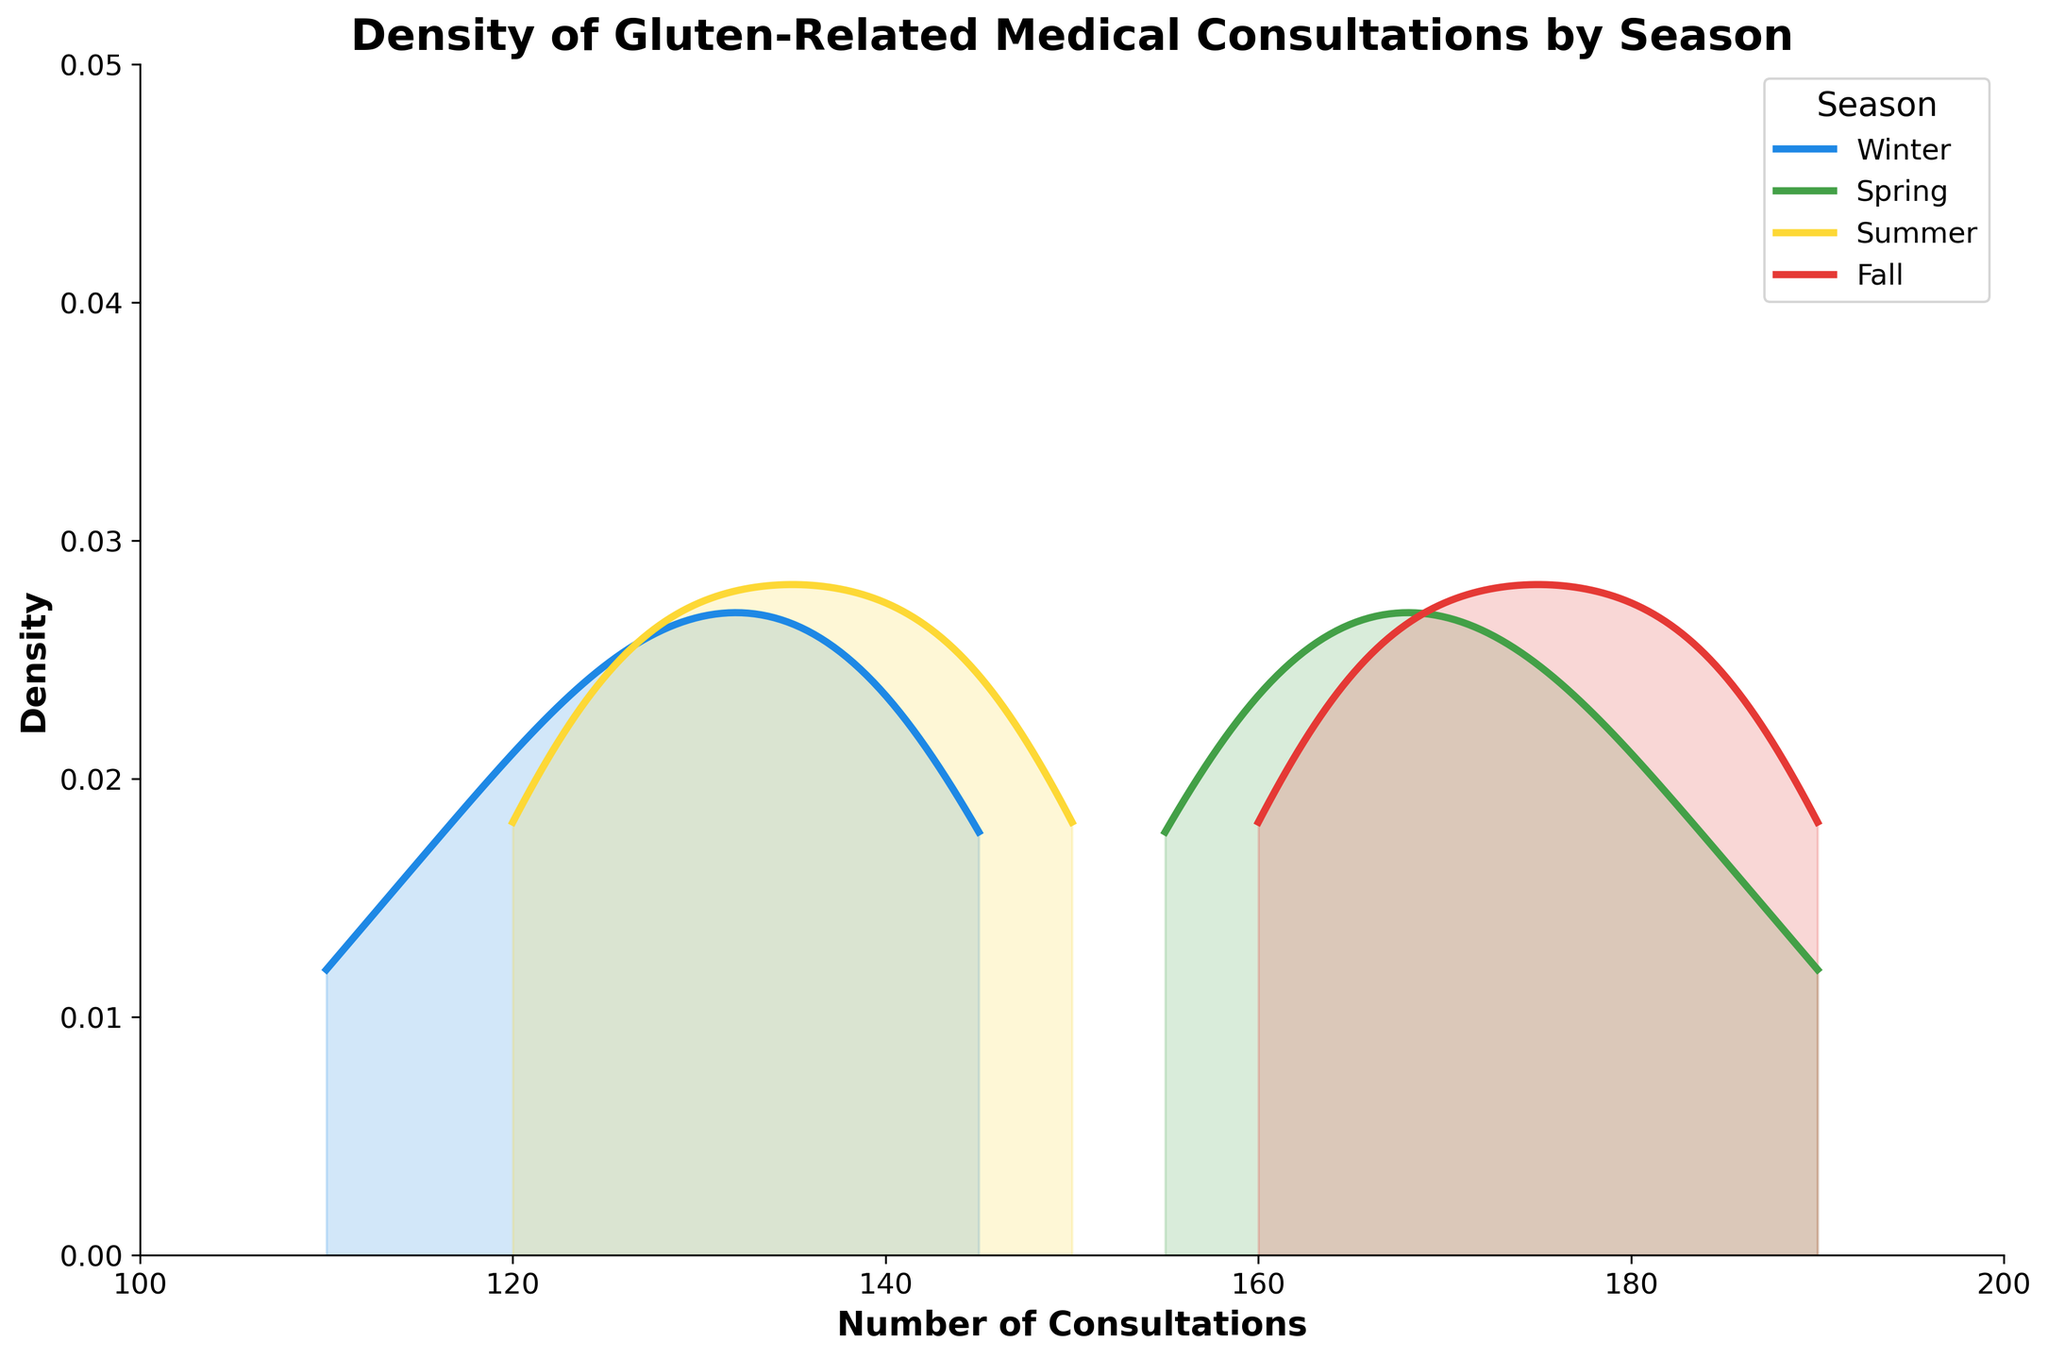What is the title of the plot? The title is displayed at the top of the plot and reads "Density of Gluten-Related Medical Consultations by Season," indicating what the plot represents.
Answer: Density of Gluten-Related Medical Consultations by Season What does the x-axis represent? The x-axis is labeled "Number of Consultations," showing that it represents how many gluten-related medical consultations occurred.
Answer: Number of Consultations What does the y-axis represent? The y-axis is labeled "Density," showing that it represents the density of consultations within each season.
Answer: Density What season has the highest density of consultations within the 120-140 range? By observing the filled density area, Winter has the highest density of consultations within the 120-140 range, indicated by the peak and filled area.
Answer: Winter How many seasons are compared in this plot? There are four distinct colors in the plot, each representing a different season: Winter, Spring, Summer, and Fall.
Answer: Four Which season shows the widest spread of consultation data? By comparing the spread along the x-axis for each season, Spring has the widest range of consultations, stretching from 155 to 190+.
Answer: Spring In which season does the density peak near 165 consultations? The density peak near 165 consultations is shown by the line and filled area for Fall, which peaks around this number.
Answer: Fall Does Summer have more or fewer consultations compared to Spring? By comparing the density plots, Summer has a lower peak and narrower range compared to the higher peak and wider spread of consultations in Spring.
Answer: Fewer Between Winter and Fall, which season had closer median consultation values? Comparing the density peaks, Winter peaks around 130-135, while Fall peaks around 170-175, showing Winter's median consultations are lower than Fall's.
Answer: Winter Which season shows the lowest density at both 120 consultations and above 180 consultations? By observing the density lines, Winter shows the lowest density at 120 consultations and values above 180.
Answer: Winter 